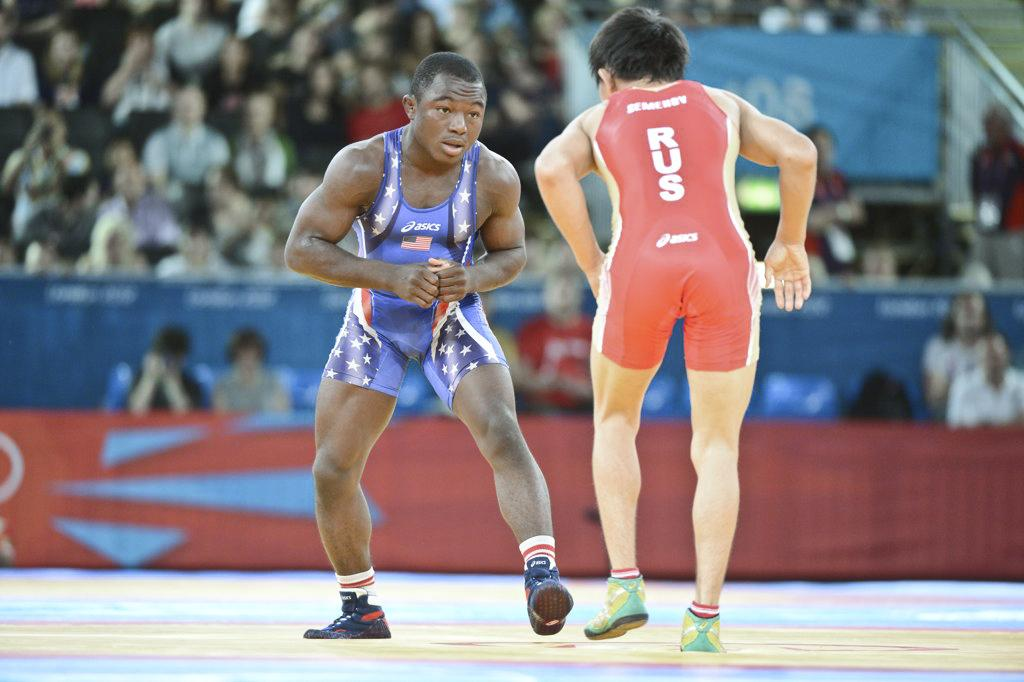<image>
Provide a brief description of the given image. Two wrestlers with one wearing a red jersey which says RUS. 